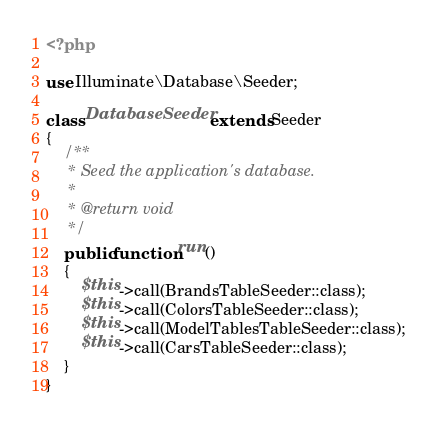Convert code to text. <code><loc_0><loc_0><loc_500><loc_500><_PHP_><?php

use Illuminate\Database\Seeder;

class DatabaseSeeder extends Seeder
{
    /**
     * Seed the application's database.
     *
     * @return void
     */
    public function run()
    {
        $this->call(BrandsTableSeeder::class);
        $this->call(ColorsTableSeeder::class);
        $this->call(ModelTablesTableSeeder::class);
        $this->call(CarsTableSeeder::class);
    }
}
</code> 